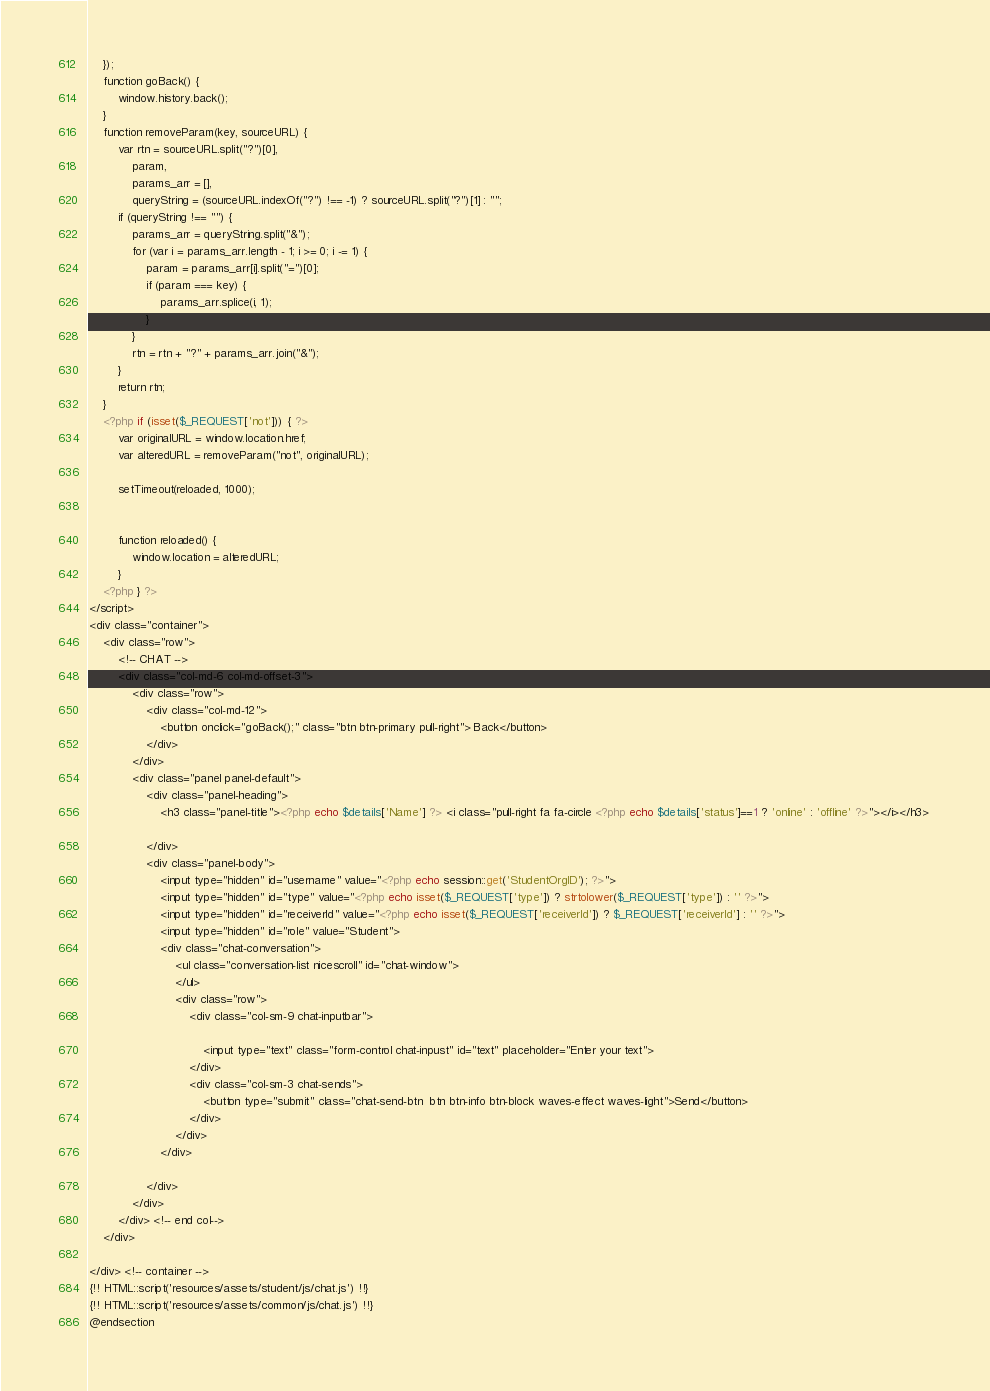Convert code to text. <code><loc_0><loc_0><loc_500><loc_500><_PHP_>    });
    function goBack() {
        window.history.back();
    }
    function removeParam(key, sourceURL) {
        var rtn = sourceURL.split("?")[0],
            param,
            params_arr = [],
            queryString = (sourceURL.indexOf("?") !== -1) ? sourceURL.split("?")[1] : "";
        if (queryString !== "") {
            params_arr = queryString.split("&");
            for (var i = params_arr.length - 1; i >= 0; i -= 1) {
                param = params_arr[i].split("=")[0];
                if (param === key) {
                    params_arr.splice(i, 1);
                }
            }
            rtn = rtn + "?" + params_arr.join("&");
        }
        return rtn;
    }
    <?php if (isset($_REQUEST['not'])) { ?> 
        var originalURL = window.location.href;
        var alteredURL = removeParam("not", originalURL);

        setTimeout(reloaded, 1000);


        function reloaded() {
            window.location = alteredURL;
        }
    <?php } ?>
</script>
<div class="container">
    <div class="row">
        <!-- CHAT -->
        <div class="col-md-6 col-md-offset-3">
            <div class="row">
                <div class="col-md-12">
                    <button onclick="goBack();" class="btn btn-primary pull-right"> Back</button>
                </div>
            </div>
            <div class="panel panel-default">
                <div class="panel-heading"> 
                    <h3 class="panel-title"><?php echo $details['Name'] ?> <i class="pull-right fa fa-circle <?php echo $details['status']==1 ? 'online' : 'offline' ?>"></i></h3> 
                    
                </div> 
                <div class="panel-body"> 
                    <input type="hidden" id="username" value="<?php echo session::get('StudentOrgID'); ?>">
                    <input type="hidden" id="type" value="<?php echo isset($_REQUEST['type']) ? strtolower($_REQUEST['type']) : '' ?>">
                    <input type="hidden" id="receiverId" value="<?php echo isset($_REQUEST['receiverId']) ? $_REQUEST['receiverId'] : '' ?>">
                    <input type="hidden" id="role" value="Student">
                    <div class="chat-conversation">
                        <ul class="conversation-list nicescroll" id="chat-window">
                        </ul>
                        <div class="row">
                            <div class="col-sm-9 chat-inputbar">
                                
                                <input type="text" class="form-control chat-inpust" id="text" placeholder="Enter your text">
                            </div>
                            <div class="col-sm-3 chat-sends">
                                <button type="submit" class="chat-send-btn  btn btn-info btn-block waves-effect waves-light">Send</button>
                            </div>
                        </div>
                    </div>
                    
                </div> 
            </div>
        </div> <!-- end col-->
    </div>

</div> <!-- container -->
{!! HTML::script('resources/assets/student/js/chat.js') !!}
{!! HTML::script('resources/assets/common/js/chat.js') !!}
@endsection   </code> 